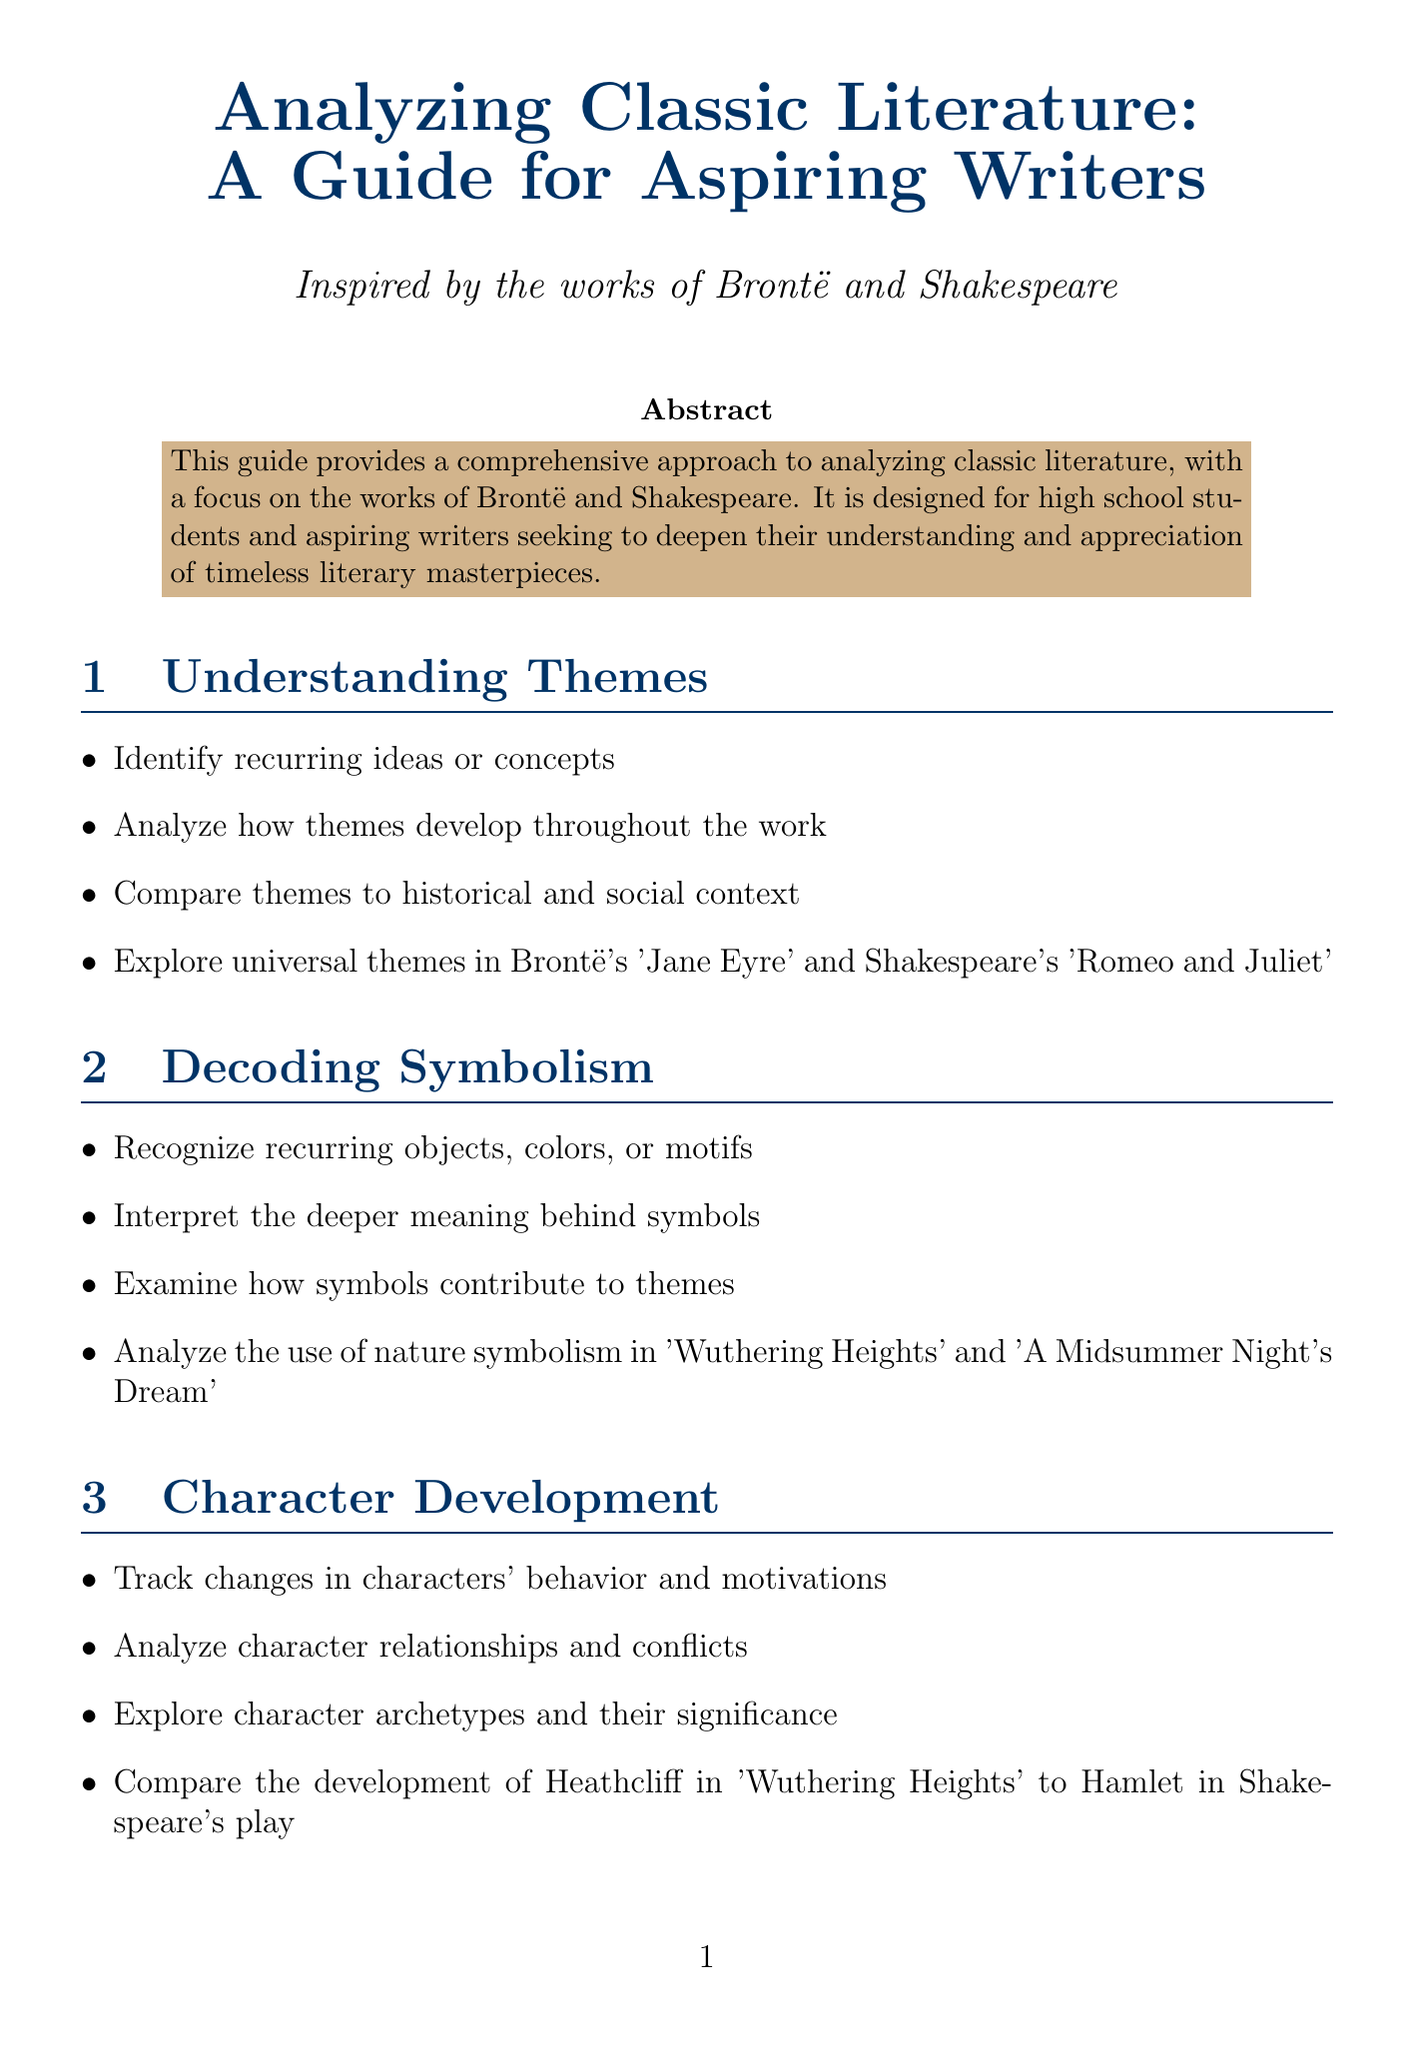What is the title of the guide? The title is prominently stated at the top of the document.
Answer: Analyzing Classic Literature: A Guide for Aspiring Writers Who are the target audience for the guide? The document explicitly mentions this in the introduction.
Answer: High school students and aspiring writers What literary device is mentioned as an exercise in the document? The document lists various techniques and includes an associated exercise.
Answer: Foreshadowing Which characters are compared in the character development section? This comparison is specifically stated in the steps of the character development section.
Answer: Heathcliff and Hamlet How many sections are there in the document? The document outlines specific sections, which can be counted.
Answer: 8 What is one of the recommended readings? The recommended readings section specifies several titles.
Answer: 'The Norton Shakespeare' edited by Stephen Greenblatt What is the purpose of the guide? The purpose is described in the introduction.
Answer: To provide a comprehensive approach to analyzing classic literature Name one online resource listed in the document. The document includes a section listing various online resources.
Answer: The Folger Shakespeare Library 